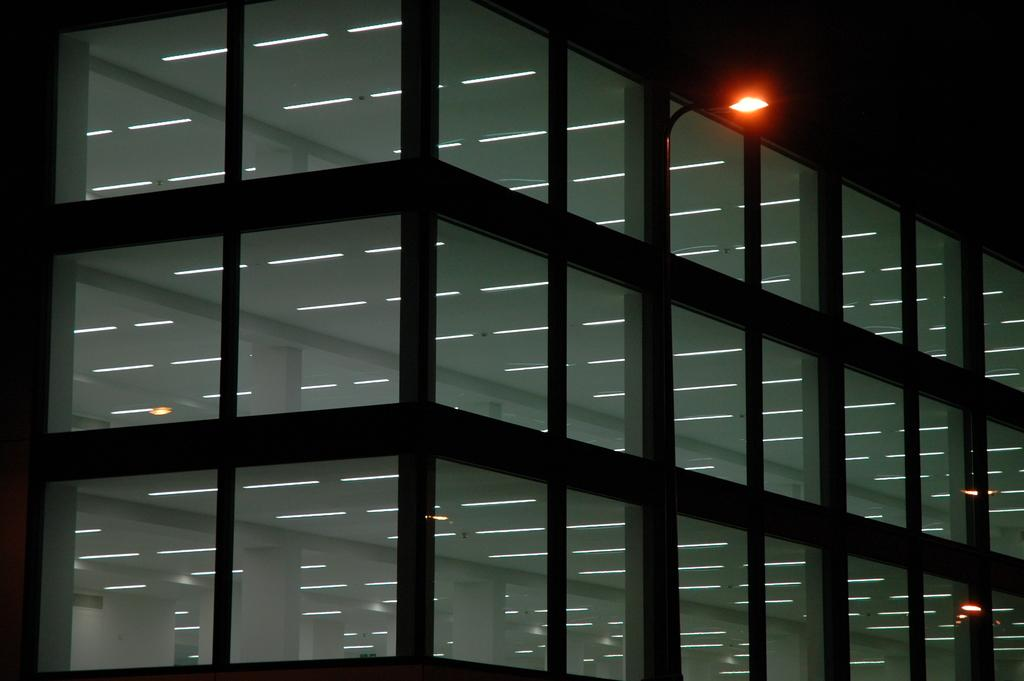What material is the building made of? The building is made of glass. Can you describe any specific features of the building? There is a red color light on the building. What type of beam can be seen supporting the glass structure in the image? There is no beam visible in the image; the building is made entirely of glass. What kind of pot is placed near the red light on the building? There is no pot present in the image; the only visible feature is the red color light on the building. 